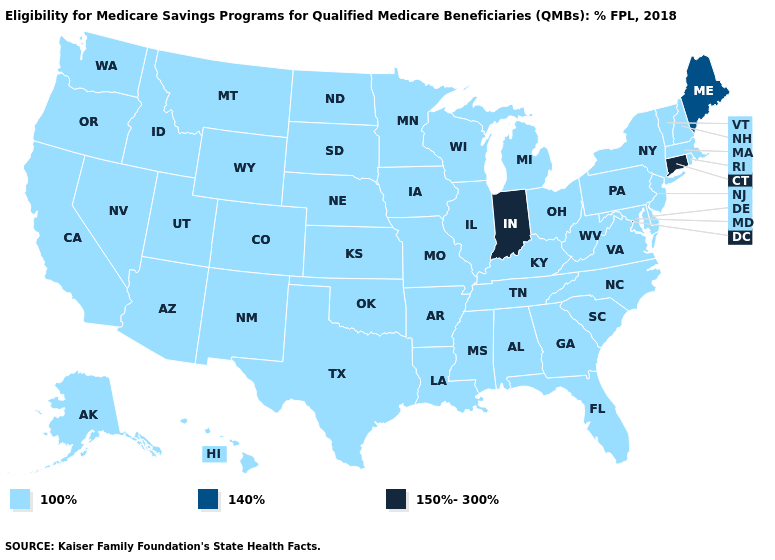Is the legend a continuous bar?
Concise answer only. No. What is the highest value in the Northeast ?
Keep it brief. 150%-300%. How many symbols are there in the legend?
Short answer required. 3. What is the value of Wisconsin?
Concise answer only. 100%. Is the legend a continuous bar?
Keep it brief. No. Does Alabama have the same value as West Virginia?
Keep it brief. Yes. Does the first symbol in the legend represent the smallest category?
Short answer required. Yes. Name the states that have a value in the range 150%-300%?
Keep it brief. Connecticut, Indiana. What is the lowest value in the USA?
Quick response, please. 100%. What is the value of Vermont?
Short answer required. 100%. Does the map have missing data?
Concise answer only. No. Among the states that border Pennsylvania , which have the lowest value?
Keep it brief. Delaware, Maryland, New Jersey, New York, Ohio, West Virginia. Name the states that have a value in the range 150%-300%?
Answer briefly. Connecticut, Indiana. Name the states that have a value in the range 140%?
Short answer required. Maine. Does Michigan have the highest value in the MidWest?
Short answer required. No. 